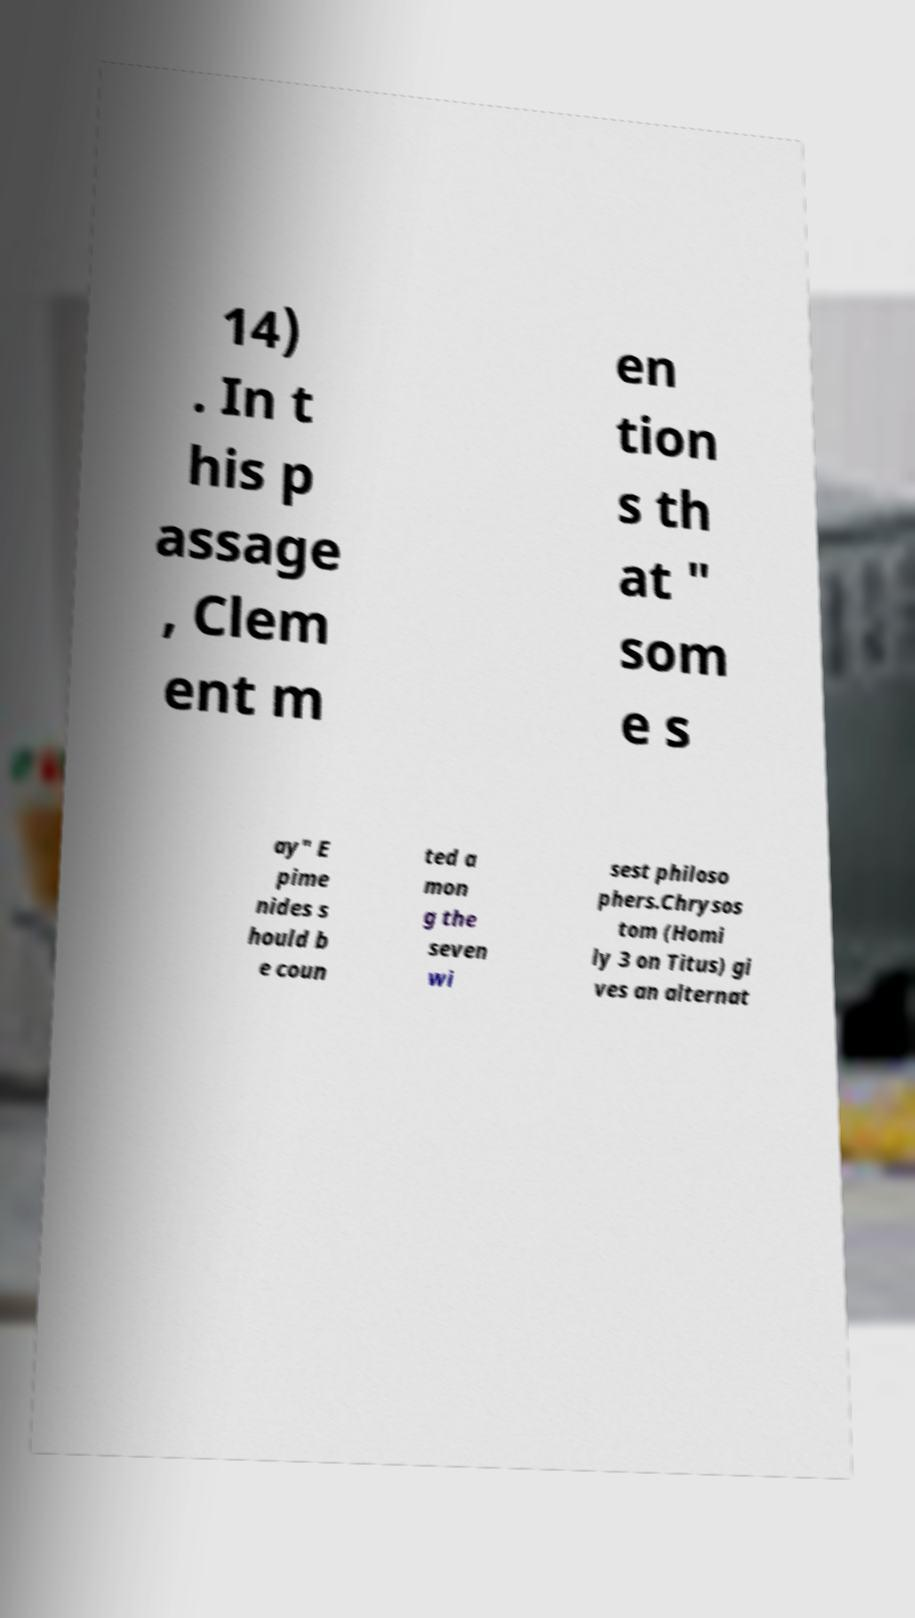What messages or text are displayed in this image? I need them in a readable, typed format. 14) . In t his p assage , Clem ent m en tion s th at " som e s ay" E pime nides s hould b e coun ted a mon g the seven wi sest philoso phers.Chrysos tom (Homi ly 3 on Titus) gi ves an alternat 